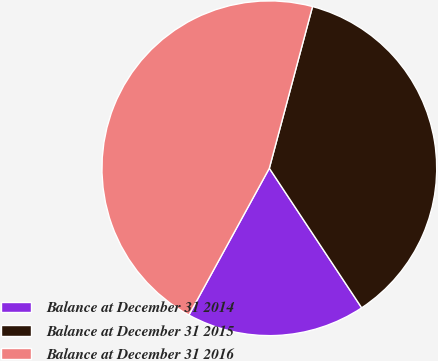Convert chart. <chart><loc_0><loc_0><loc_500><loc_500><pie_chart><fcel>Balance at December 31 2014<fcel>Balance at December 31 2015<fcel>Balance at December 31 2016<nl><fcel>17.28%<fcel>36.54%<fcel>46.18%<nl></chart> 